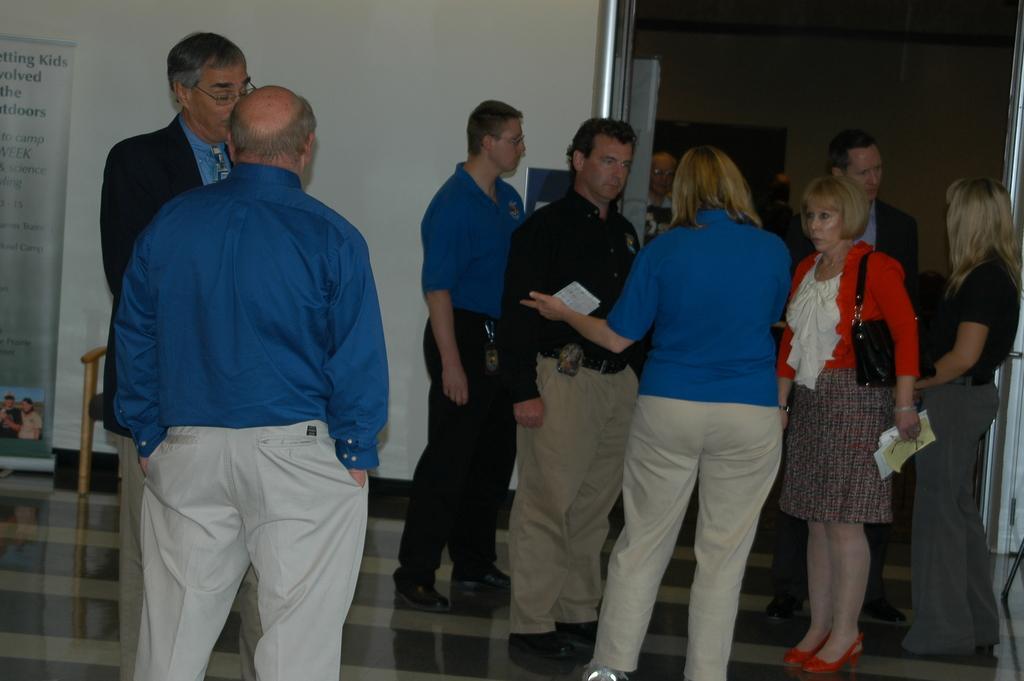Please provide a concise description of this image. In this image in the foreground we can see a bald guy, and there are many people standing on the floor. 